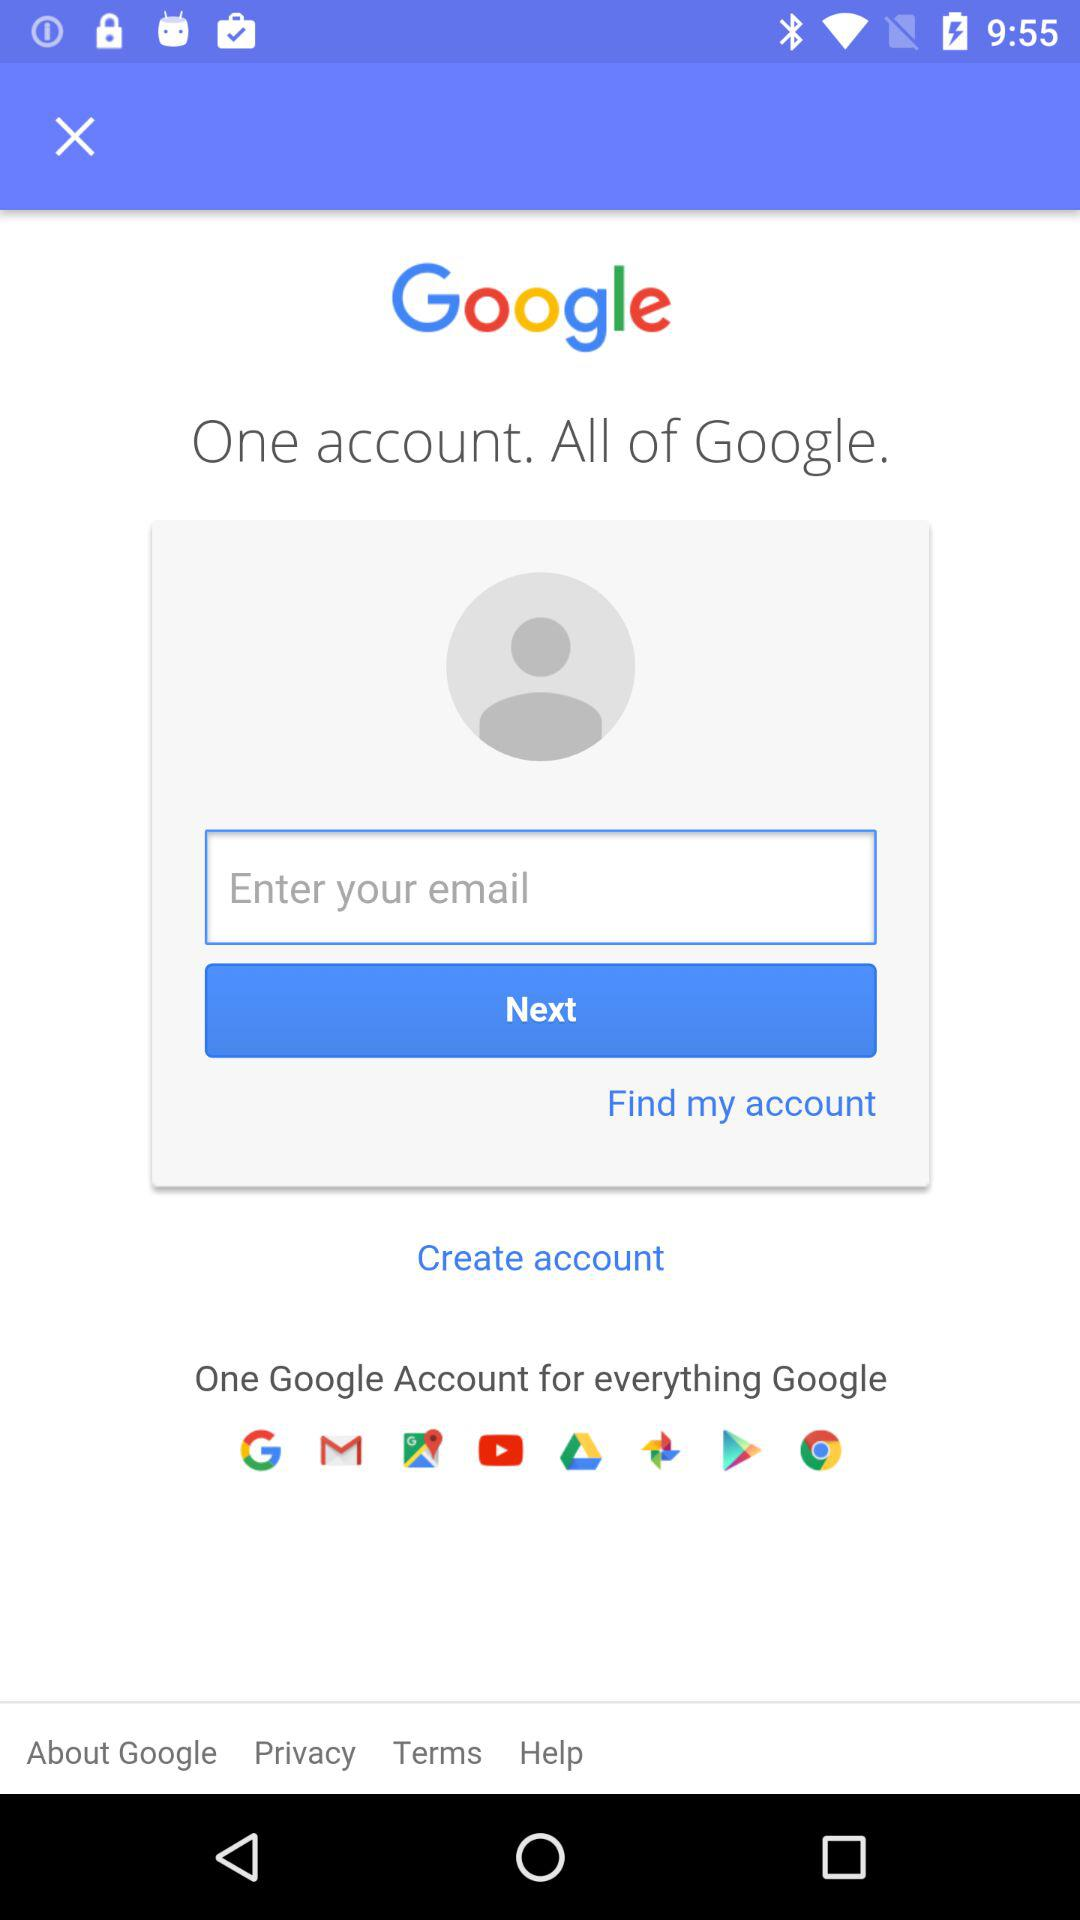What is the requirement to find my account?
When the provided information is insufficient, respond with <no answer>. <no answer> 